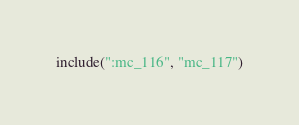Convert code to text. <code><loc_0><loc_0><loc_500><loc_500><_Kotlin_>include(":mc_116", "mc_117")</code> 